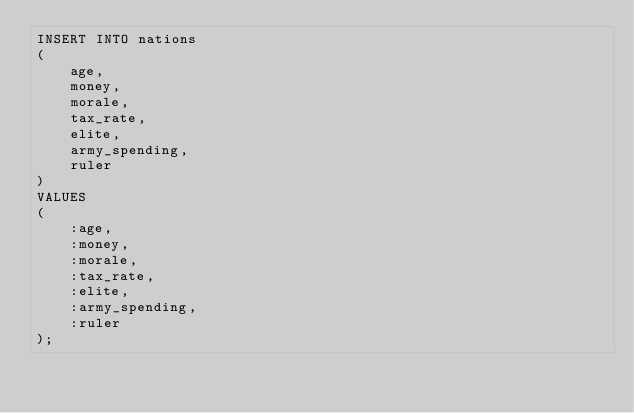<code> <loc_0><loc_0><loc_500><loc_500><_SQL_>INSERT INTO nations
(
    age,
    money,
    morale,
    tax_rate,
    elite,
    army_spending,
    ruler
)
VALUES
(
    :age,
    :money,
    :morale,
    :tax_rate,
    :elite,
    :army_spending,
    :ruler
);
</code> 